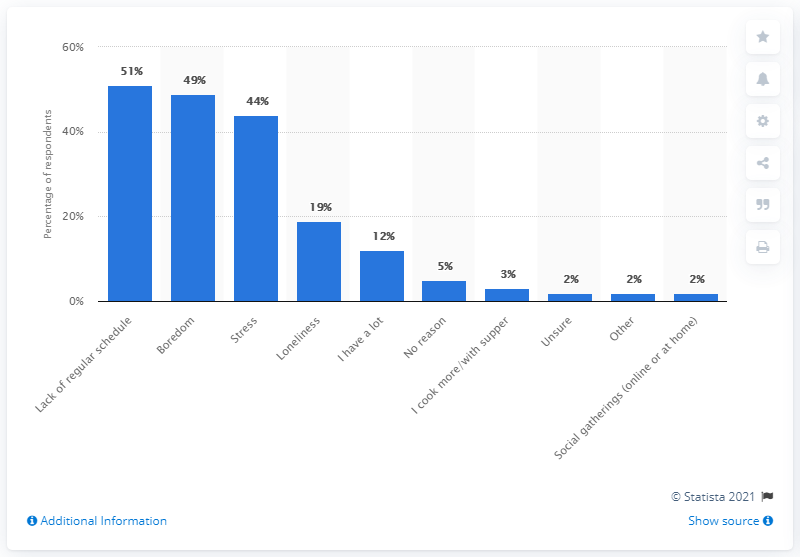Give some essential details in this illustration. According to a survey conducted by the Canadian government, 51% of Canadians cited the lack of a regular schedule as one of the reasons for the increase in alcohol consumption. 